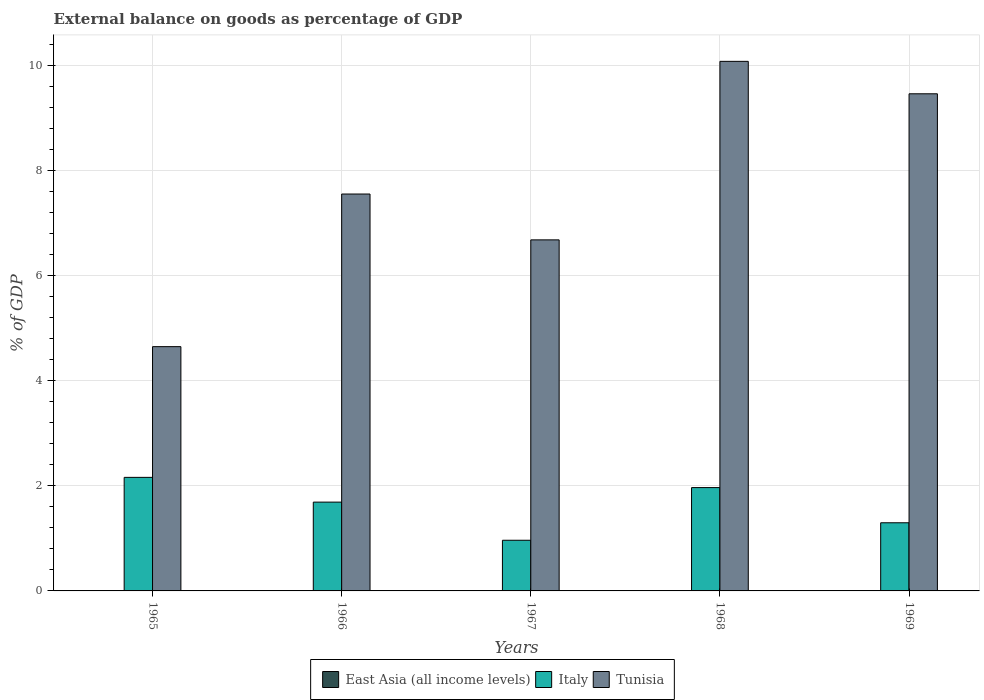How many different coloured bars are there?
Offer a very short reply. 2. How many groups of bars are there?
Offer a terse response. 5. Are the number of bars on each tick of the X-axis equal?
Make the answer very short. Yes. How many bars are there on the 3rd tick from the left?
Ensure brevity in your answer.  2. What is the label of the 3rd group of bars from the left?
Provide a short and direct response. 1967. What is the external balance on goods as percentage of GDP in East Asia (all income levels) in 1967?
Keep it short and to the point. 0. Across all years, what is the maximum external balance on goods as percentage of GDP in Italy?
Keep it short and to the point. 2.16. In which year was the external balance on goods as percentage of GDP in Italy maximum?
Provide a succinct answer. 1965. What is the total external balance on goods as percentage of GDP in Tunisia in the graph?
Your answer should be very brief. 38.44. What is the difference between the external balance on goods as percentage of GDP in Tunisia in 1968 and that in 1969?
Provide a short and direct response. 0.62. What is the difference between the external balance on goods as percentage of GDP in Tunisia in 1965 and the external balance on goods as percentage of GDP in Italy in 1967?
Offer a very short reply. 3.69. What is the average external balance on goods as percentage of GDP in East Asia (all income levels) per year?
Keep it short and to the point. 0. In the year 1966, what is the difference between the external balance on goods as percentage of GDP in Tunisia and external balance on goods as percentage of GDP in Italy?
Give a very brief answer. 5.87. What is the ratio of the external balance on goods as percentage of GDP in Italy in 1965 to that in 1969?
Give a very brief answer. 1.67. Is the difference between the external balance on goods as percentage of GDP in Tunisia in 1966 and 1967 greater than the difference between the external balance on goods as percentage of GDP in Italy in 1966 and 1967?
Offer a terse response. Yes. What is the difference between the highest and the second highest external balance on goods as percentage of GDP in Italy?
Keep it short and to the point. 0.19. What is the difference between the highest and the lowest external balance on goods as percentage of GDP in Italy?
Give a very brief answer. 1.2. In how many years, is the external balance on goods as percentage of GDP in Tunisia greater than the average external balance on goods as percentage of GDP in Tunisia taken over all years?
Offer a very short reply. 2. Is it the case that in every year, the sum of the external balance on goods as percentage of GDP in Tunisia and external balance on goods as percentage of GDP in Italy is greater than the external balance on goods as percentage of GDP in East Asia (all income levels)?
Give a very brief answer. Yes. How many bars are there?
Provide a short and direct response. 10. Are all the bars in the graph horizontal?
Your response must be concise. No. Does the graph contain any zero values?
Offer a terse response. Yes. Where does the legend appear in the graph?
Give a very brief answer. Bottom center. How are the legend labels stacked?
Give a very brief answer. Horizontal. What is the title of the graph?
Provide a succinct answer. External balance on goods as percentage of GDP. What is the label or title of the Y-axis?
Give a very brief answer. % of GDP. What is the % of GDP in East Asia (all income levels) in 1965?
Offer a very short reply. 0. What is the % of GDP in Italy in 1965?
Offer a very short reply. 2.16. What is the % of GDP of Tunisia in 1965?
Ensure brevity in your answer.  4.65. What is the % of GDP of Italy in 1966?
Your response must be concise. 1.69. What is the % of GDP of Tunisia in 1966?
Your answer should be compact. 7.56. What is the % of GDP of Italy in 1967?
Keep it short and to the point. 0.96. What is the % of GDP in Tunisia in 1967?
Your response must be concise. 6.68. What is the % of GDP of Italy in 1968?
Your answer should be compact. 1.97. What is the % of GDP of Tunisia in 1968?
Offer a very short reply. 10.08. What is the % of GDP of East Asia (all income levels) in 1969?
Offer a very short reply. 0. What is the % of GDP in Italy in 1969?
Give a very brief answer. 1.3. What is the % of GDP in Tunisia in 1969?
Offer a very short reply. 9.47. Across all years, what is the maximum % of GDP of Italy?
Provide a short and direct response. 2.16. Across all years, what is the maximum % of GDP of Tunisia?
Your answer should be very brief. 10.08. Across all years, what is the minimum % of GDP in Italy?
Provide a succinct answer. 0.96. Across all years, what is the minimum % of GDP in Tunisia?
Make the answer very short. 4.65. What is the total % of GDP of East Asia (all income levels) in the graph?
Offer a terse response. 0. What is the total % of GDP of Italy in the graph?
Keep it short and to the point. 8.08. What is the total % of GDP of Tunisia in the graph?
Provide a succinct answer. 38.44. What is the difference between the % of GDP of Italy in 1965 and that in 1966?
Your response must be concise. 0.47. What is the difference between the % of GDP in Tunisia in 1965 and that in 1966?
Provide a succinct answer. -2.91. What is the difference between the % of GDP in Italy in 1965 and that in 1967?
Provide a succinct answer. 1.2. What is the difference between the % of GDP in Tunisia in 1965 and that in 1967?
Keep it short and to the point. -2.03. What is the difference between the % of GDP of Italy in 1965 and that in 1968?
Keep it short and to the point. 0.19. What is the difference between the % of GDP in Tunisia in 1965 and that in 1968?
Your response must be concise. -5.43. What is the difference between the % of GDP in Italy in 1965 and that in 1969?
Provide a succinct answer. 0.86. What is the difference between the % of GDP in Tunisia in 1965 and that in 1969?
Provide a short and direct response. -4.81. What is the difference between the % of GDP in Italy in 1966 and that in 1967?
Give a very brief answer. 0.73. What is the difference between the % of GDP of Tunisia in 1966 and that in 1967?
Offer a very short reply. 0.87. What is the difference between the % of GDP in Italy in 1966 and that in 1968?
Your response must be concise. -0.28. What is the difference between the % of GDP of Tunisia in 1966 and that in 1968?
Your answer should be very brief. -2.53. What is the difference between the % of GDP of Italy in 1966 and that in 1969?
Give a very brief answer. 0.39. What is the difference between the % of GDP in Tunisia in 1966 and that in 1969?
Provide a succinct answer. -1.91. What is the difference between the % of GDP of Italy in 1967 and that in 1968?
Give a very brief answer. -1. What is the difference between the % of GDP of Tunisia in 1967 and that in 1968?
Keep it short and to the point. -3.4. What is the difference between the % of GDP of Italy in 1967 and that in 1969?
Make the answer very short. -0.33. What is the difference between the % of GDP in Tunisia in 1967 and that in 1969?
Give a very brief answer. -2.78. What is the difference between the % of GDP of Italy in 1968 and that in 1969?
Give a very brief answer. 0.67. What is the difference between the % of GDP in Tunisia in 1968 and that in 1969?
Your answer should be compact. 0.62. What is the difference between the % of GDP of Italy in 1965 and the % of GDP of Tunisia in 1966?
Your answer should be compact. -5.39. What is the difference between the % of GDP in Italy in 1965 and the % of GDP in Tunisia in 1967?
Keep it short and to the point. -4.52. What is the difference between the % of GDP in Italy in 1965 and the % of GDP in Tunisia in 1968?
Your response must be concise. -7.92. What is the difference between the % of GDP of Italy in 1965 and the % of GDP of Tunisia in 1969?
Your answer should be compact. -7.3. What is the difference between the % of GDP of Italy in 1966 and the % of GDP of Tunisia in 1967?
Provide a short and direct response. -4.99. What is the difference between the % of GDP of Italy in 1966 and the % of GDP of Tunisia in 1968?
Ensure brevity in your answer.  -8.39. What is the difference between the % of GDP in Italy in 1966 and the % of GDP in Tunisia in 1969?
Your answer should be compact. -7.77. What is the difference between the % of GDP in Italy in 1967 and the % of GDP in Tunisia in 1968?
Give a very brief answer. -9.12. What is the difference between the % of GDP in Italy in 1967 and the % of GDP in Tunisia in 1969?
Offer a terse response. -8.5. What is the difference between the % of GDP of Italy in 1968 and the % of GDP of Tunisia in 1969?
Your answer should be very brief. -7.5. What is the average % of GDP of East Asia (all income levels) per year?
Your answer should be compact. 0. What is the average % of GDP in Italy per year?
Keep it short and to the point. 1.62. What is the average % of GDP of Tunisia per year?
Your answer should be very brief. 7.69. In the year 1965, what is the difference between the % of GDP of Italy and % of GDP of Tunisia?
Your response must be concise. -2.49. In the year 1966, what is the difference between the % of GDP in Italy and % of GDP in Tunisia?
Provide a short and direct response. -5.87. In the year 1967, what is the difference between the % of GDP in Italy and % of GDP in Tunisia?
Your response must be concise. -5.72. In the year 1968, what is the difference between the % of GDP in Italy and % of GDP in Tunisia?
Keep it short and to the point. -8.12. In the year 1969, what is the difference between the % of GDP of Italy and % of GDP of Tunisia?
Provide a succinct answer. -8.17. What is the ratio of the % of GDP in Italy in 1965 to that in 1966?
Offer a terse response. 1.28. What is the ratio of the % of GDP of Tunisia in 1965 to that in 1966?
Provide a succinct answer. 0.62. What is the ratio of the % of GDP in Italy in 1965 to that in 1967?
Offer a very short reply. 2.24. What is the ratio of the % of GDP of Tunisia in 1965 to that in 1967?
Provide a short and direct response. 0.7. What is the ratio of the % of GDP of Italy in 1965 to that in 1968?
Your answer should be compact. 1.1. What is the ratio of the % of GDP in Tunisia in 1965 to that in 1968?
Provide a short and direct response. 0.46. What is the ratio of the % of GDP of Italy in 1965 to that in 1969?
Provide a short and direct response. 1.67. What is the ratio of the % of GDP of Tunisia in 1965 to that in 1969?
Make the answer very short. 0.49. What is the ratio of the % of GDP of Italy in 1966 to that in 1967?
Offer a terse response. 1.75. What is the ratio of the % of GDP of Tunisia in 1966 to that in 1967?
Your answer should be compact. 1.13. What is the ratio of the % of GDP in Italy in 1966 to that in 1968?
Offer a very short reply. 0.86. What is the ratio of the % of GDP of Tunisia in 1966 to that in 1968?
Give a very brief answer. 0.75. What is the ratio of the % of GDP of Italy in 1966 to that in 1969?
Provide a short and direct response. 1.3. What is the ratio of the % of GDP of Tunisia in 1966 to that in 1969?
Give a very brief answer. 0.8. What is the ratio of the % of GDP in Italy in 1967 to that in 1968?
Offer a very short reply. 0.49. What is the ratio of the % of GDP of Tunisia in 1967 to that in 1968?
Give a very brief answer. 0.66. What is the ratio of the % of GDP of Italy in 1967 to that in 1969?
Provide a succinct answer. 0.74. What is the ratio of the % of GDP in Tunisia in 1967 to that in 1969?
Your response must be concise. 0.71. What is the ratio of the % of GDP of Italy in 1968 to that in 1969?
Provide a succinct answer. 1.52. What is the ratio of the % of GDP of Tunisia in 1968 to that in 1969?
Keep it short and to the point. 1.07. What is the difference between the highest and the second highest % of GDP of Italy?
Make the answer very short. 0.19. What is the difference between the highest and the second highest % of GDP of Tunisia?
Keep it short and to the point. 0.62. What is the difference between the highest and the lowest % of GDP of Italy?
Offer a very short reply. 1.2. What is the difference between the highest and the lowest % of GDP in Tunisia?
Ensure brevity in your answer.  5.43. 